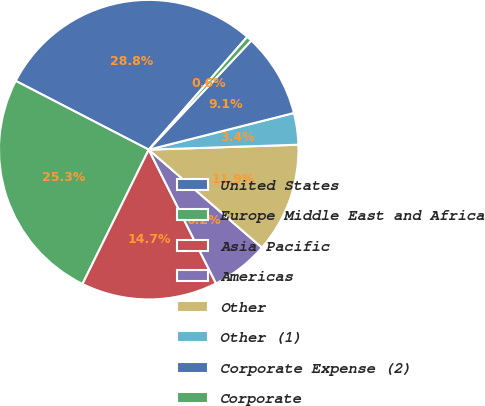<chart> <loc_0><loc_0><loc_500><loc_500><pie_chart><fcel>United States<fcel>Europe Middle East and Africa<fcel>Asia Pacific<fcel>Americas<fcel>Other<fcel>Other (1)<fcel>Corporate Expense (2)<fcel>Corporate<nl><fcel>28.83%<fcel>25.3%<fcel>14.71%<fcel>6.23%<fcel>11.88%<fcel>3.41%<fcel>9.06%<fcel>0.58%<nl></chart> 